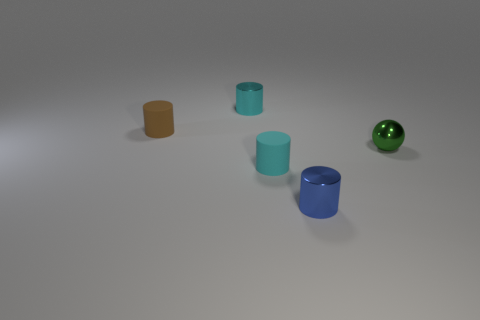Do the green thing and the small brown rubber object have the same shape?
Your answer should be compact. No. There is a cyan cylinder that is made of the same material as the ball; what size is it?
Your answer should be compact. Small. Is the number of metallic spheres less than the number of matte objects?
Your answer should be compact. Yes. What number of large things are brown objects or metallic cylinders?
Your response must be concise. 0. What number of tiny shiny things are in front of the small brown thing and behind the small brown rubber cylinder?
Offer a terse response. 0. Are there more small rubber things than blue metallic cylinders?
Make the answer very short. Yes. How many other things are there of the same shape as the blue shiny object?
Your response must be concise. 3. There is a cylinder that is in front of the small brown matte cylinder and behind the tiny blue metal cylinder; what material is it?
Offer a terse response. Rubber. What size is the sphere?
Provide a succinct answer. Small. What number of metallic objects are behind the tiny shiny cylinder to the right of the tiny metallic object that is to the left of the small blue shiny thing?
Offer a very short reply. 2. 